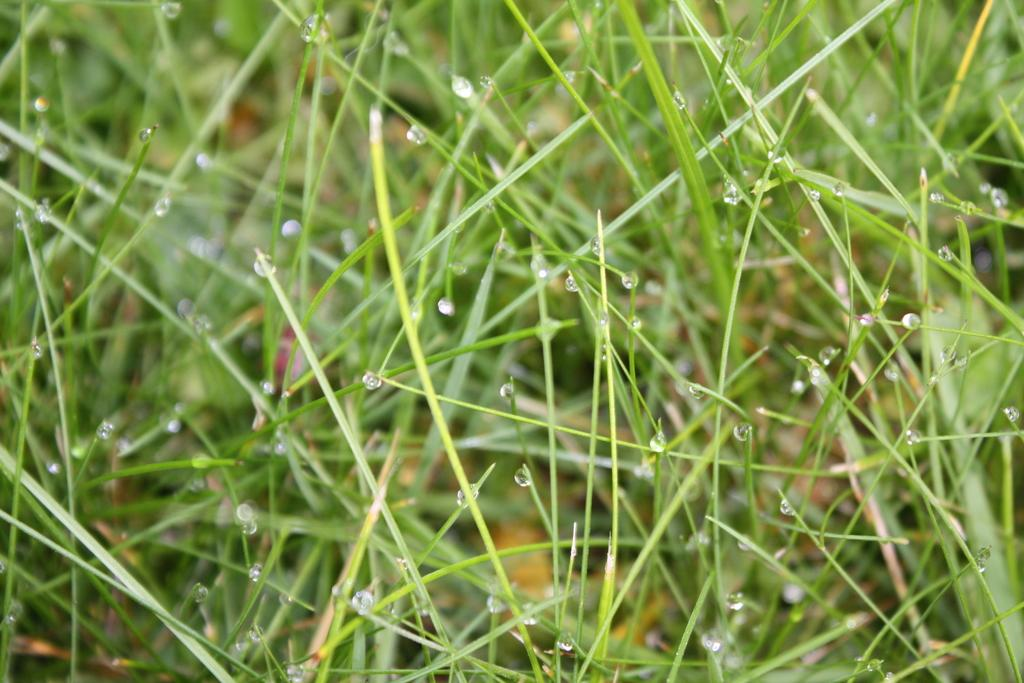What is the condition of the plants in the image? There are water droplets on the plants in the image. Can you describe the appearance of the water droplets? The water droplets appear to be small and glistening on the plants. What might be the cause of the water droplets on the plants? The water droplets could be the result of recent watering or morning dew. What type of can is visible in the image? There is no can present in the image; it only features plants with water droplets. 